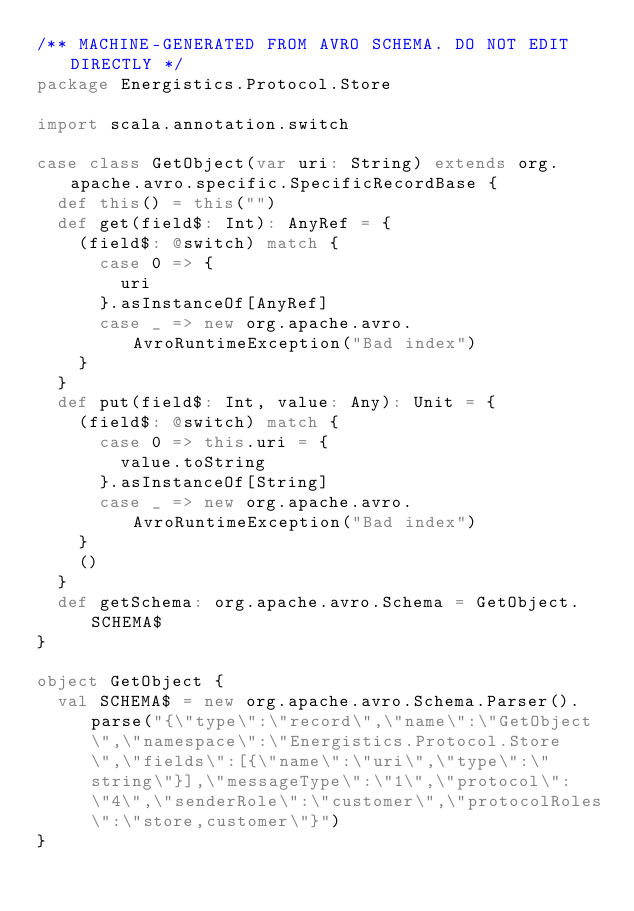Convert code to text. <code><loc_0><loc_0><loc_500><loc_500><_Scala_>/** MACHINE-GENERATED FROM AVRO SCHEMA. DO NOT EDIT DIRECTLY */
package Energistics.Protocol.Store

import scala.annotation.switch

case class GetObject(var uri: String) extends org.apache.avro.specific.SpecificRecordBase {
  def this() = this("")
  def get(field$: Int): AnyRef = {
    (field$: @switch) match {
      case 0 => {
        uri
      }.asInstanceOf[AnyRef]
      case _ => new org.apache.avro.AvroRuntimeException("Bad index")
    }
  }
  def put(field$: Int, value: Any): Unit = {
    (field$: @switch) match {
      case 0 => this.uri = {
        value.toString
      }.asInstanceOf[String]
      case _ => new org.apache.avro.AvroRuntimeException("Bad index")
    }
    ()
  }
  def getSchema: org.apache.avro.Schema = GetObject.SCHEMA$
}

object GetObject {
  val SCHEMA$ = new org.apache.avro.Schema.Parser().parse("{\"type\":\"record\",\"name\":\"GetObject\",\"namespace\":\"Energistics.Protocol.Store\",\"fields\":[{\"name\":\"uri\",\"type\":\"string\"}],\"messageType\":\"1\",\"protocol\":\"4\",\"senderRole\":\"customer\",\"protocolRoles\":\"store,customer\"}")
}</code> 